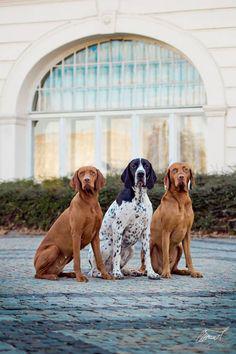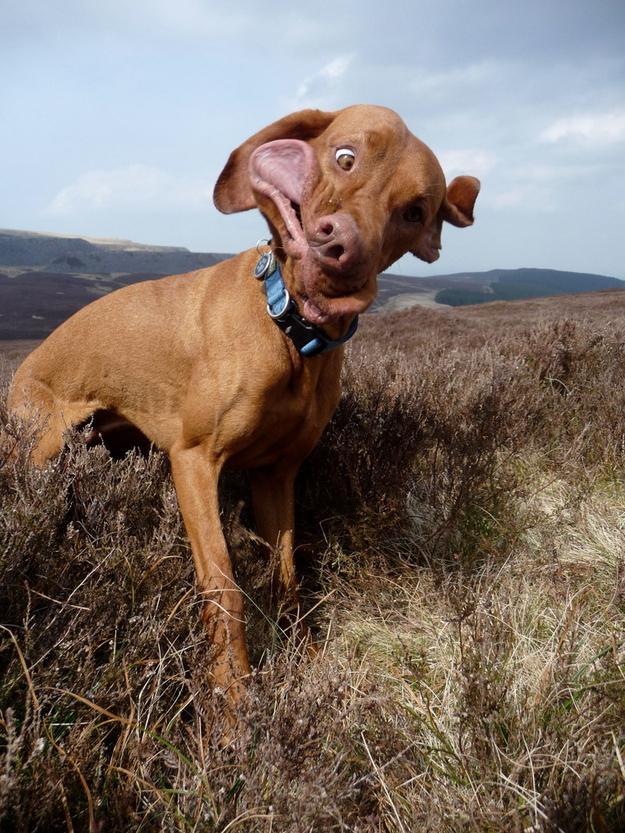The first image is the image on the left, the second image is the image on the right. Considering the images on both sides, is "The left image contains at least two dogs." valid? Answer yes or no. Yes. The first image is the image on the left, the second image is the image on the right. Assess this claim about the two images: "One red-orange dog is splashing through the water in one image, and the other image features at least one red-orange dog on a surface above the water.". Correct or not? Answer yes or no. No. 